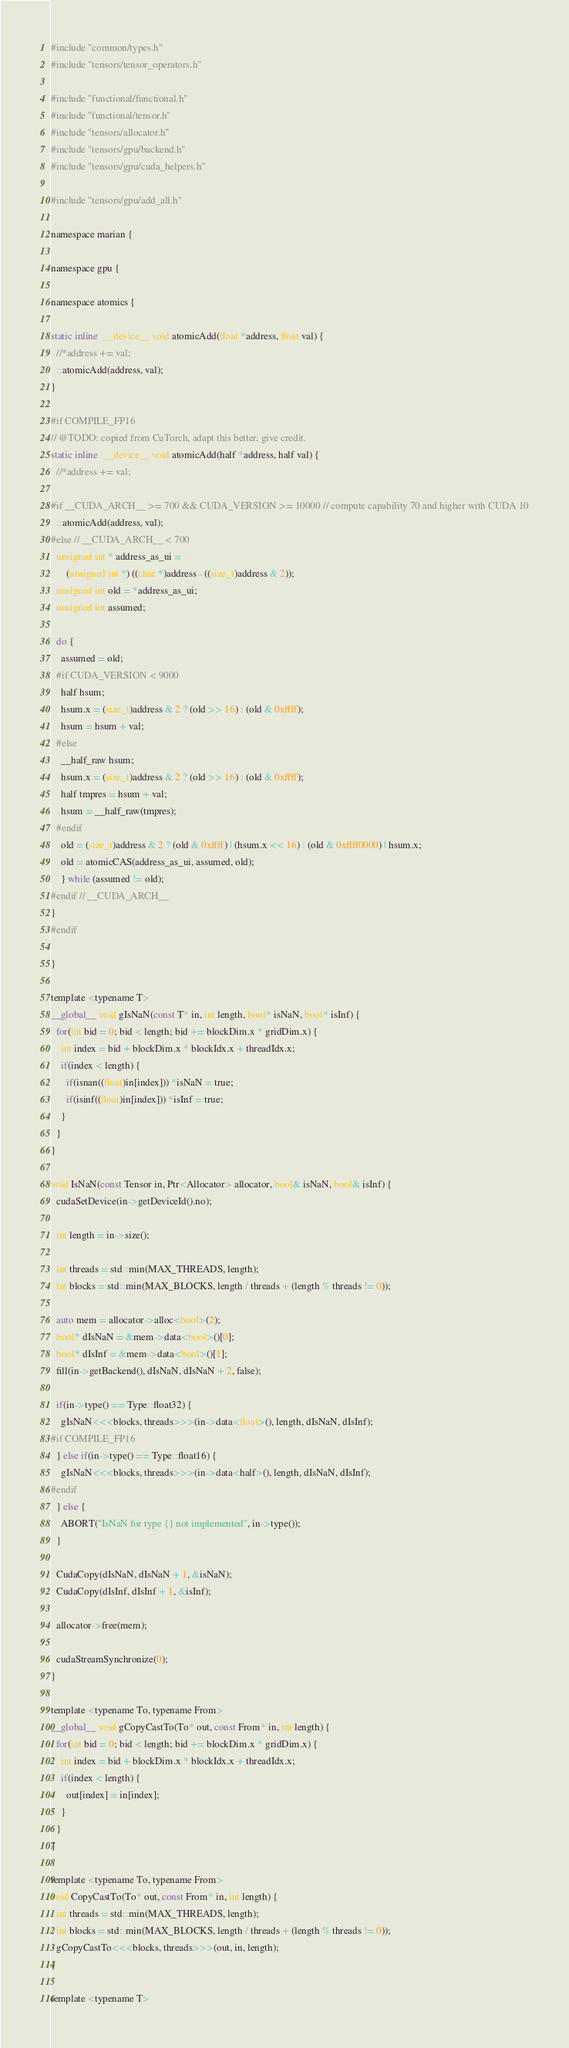Convert code to text. <code><loc_0><loc_0><loc_500><loc_500><_Cuda_>#include "common/types.h"
#include "tensors/tensor_operators.h"

#include "functional/functional.h"
#include "functional/tensor.h"
#include "tensors/allocator.h"
#include "tensors/gpu/backend.h"
#include "tensors/gpu/cuda_helpers.h"

#include "tensors/gpu/add_all.h"

namespace marian {

namespace gpu {

namespace atomics {

static inline  __device__ void atomicAdd(float *address, float val) {
  //*address += val;
  ::atomicAdd(address, val);
}

#if COMPILE_FP16
// @TODO: copied from CuTorch, adapt this better, give credit.
static inline  __device__ void atomicAdd(half *address, half val) {
  //*address += val;

#if __CUDA_ARCH__ >= 700 && CUDA_VERSION >= 10000 // compute capability 70 and higher with CUDA 10
  ::atomicAdd(address, val);
#else // __CUDA_ARCH__ < 700
  unsigned int * address_as_ui =
      (unsigned int *) ((char *)address - ((size_t)address & 2));
  unsigned int old = *address_as_ui;
  unsigned int assumed;

  do {
    assumed = old;
  #if CUDA_VERSION < 9000
    half hsum;
    hsum.x = (size_t)address & 2 ? (old >> 16) : (old & 0xffff);
    hsum = hsum + val;
  #else
    __half_raw hsum;
    hsum.x = (size_t)address & 2 ? (old >> 16) : (old & 0xffff);
    half tmpres = hsum + val;
    hsum = __half_raw(tmpres);
  #endif
    old = (size_t)address & 2 ? (old & 0xffff) | (hsum.x << 16) : (old & 0xffff0000) | hsum.x;
    old = atomicCAS(address_as_ui, assumed, old);
    } while (assumed != old);
#endif // __CUDA_ARCH__
}
#endif

}

template <typename T>
__global__ void gIsNaN(const T* in, int length, bool* isNaN, bool* isInf) {
  for(int bid = 0; bid < length; bid += blockDim.x * gridDim.x) {
    int index = bid + blockDim.x * blockIdx.x + threadIdx.x;
    if(index < length) {
      if(isnan((float)in[index])) *isNaN = true;
      if(isinf((float)in[index])) *isInf = true;
    }
  }
}

void IsNaN(const Tensor in, Ptr<Allocator> allocator, bool& isNaN, bool& isInf) {
  cudaSetDevice(in->getDeviceId().no);

  int length = in->size();

  int threads = std::min(MAX_THREADS, length);
  int blocks = std::min(MAX_BLOCKS, length / threads + (length % threads != 0));

  auto mem = allocator->alloc<bool>(2);
  bool* dIsNaN = &mem->data<bool>()[0];
  bool* dIsInf = &mem->data<bool>()[1];
  fill(in->getBackend(), dIsNaN, dIsNaN + 2, false);

  if(in->type() == Type::float32) {
    gIsNaN<<<blocks, threads>>>(in->data<float>(), length, dIsNaN, dIsInf);
#if COMPILE_FP16
  } else if(in->type() == Type::float16) {
    gIsNaN<<<blocks, threads>>>(in->data<half>(), length, dIsNaN, dIsInf);
#endif
  } else {
    ABORT("IsNaN for type {} not implemented", in->type());
  }

  CudaCopy(dIsNaN, dIsNaN + 1, &isNaN);
  CudaCopy(dIsInf, dIsInf + 1, &isInf);

  allocator->free(mem);

  cudaStreamSynchronize(0);
}

template <typename To, typename From>
__global__ void gCopyCastTo(To* out, const From* in, int length) {
  for(int bid = 0; bid < length; bid += blockDim.x * gridDim.x) {
    int index = bid + blockDim.x * blockIdx.x + threadIdx.x;
    if(index < length) {
      out[index] = in[index];
    }
  }
}

template <typename To, typename From>
void CopyCastTo(To* out, const From* in, int length) {
  int threads = std::min(MAX_THREADS, length);
  int blocks = std::min(MAX_BLOCKS, length / threads + (length % threads != 0));
  gCopyCastTo<<<blocks, threads>>>(out, in, length);
}

template <typename T></code> 